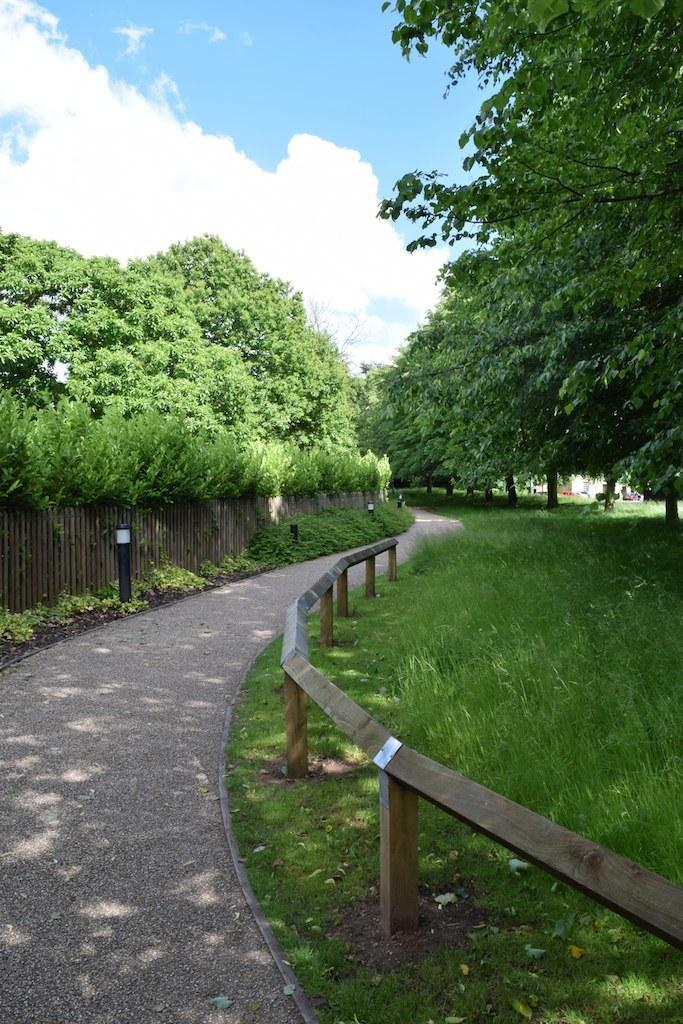What type of surface can be seen in the image? The ground is visible in the image. What type of vegetation is present in the image? There is grass, plants, and trees in the image. What structures can be seen in the image? There is a fence and poles in the image. What is visible in the sky in the image? The sky is visible in the image, and clouds are present. What type of beast can be seen feasting on flesh in the image? There is no beast or flesh present in the image. 